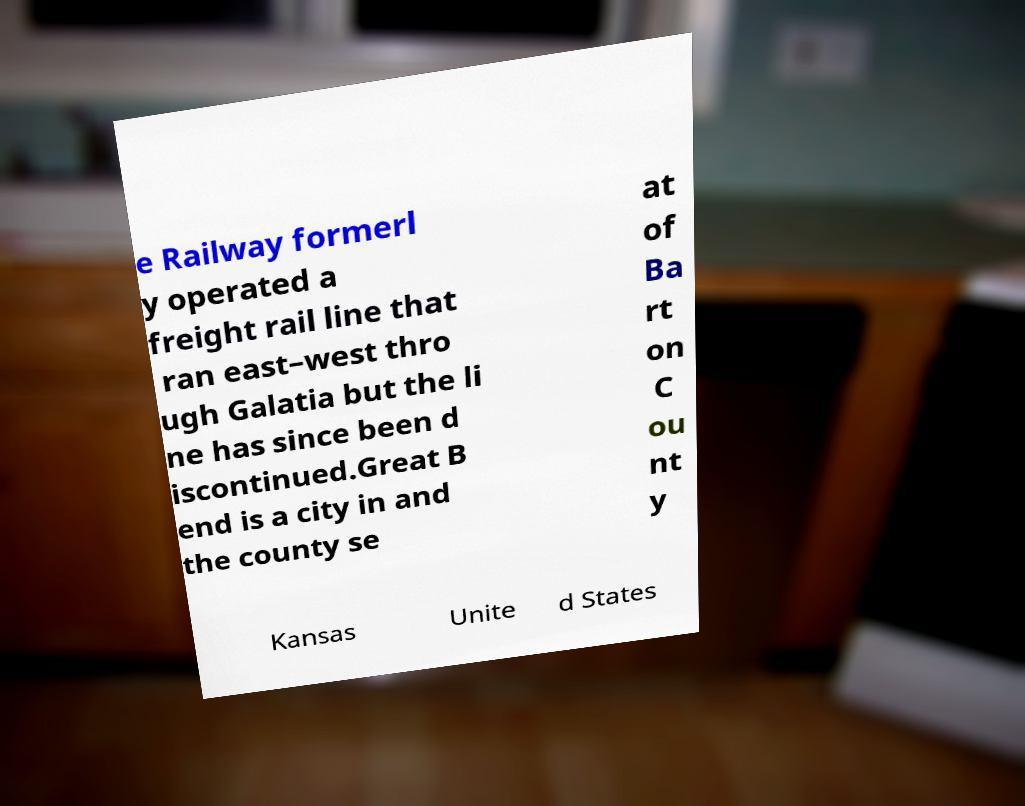Can you read and provide the text displayed in the image?This photo seems to have some interesting text. Can you extract and type it out for me? e Railway formerl y operated a freight rail line that ran east–west thro ugh Galatia but the li ne has since been d iscontinued.Great B end is a city in and the county se at of Ba rt on C ou nt y Kansas Unite d States 